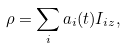Convert formula to latex. <formula><loc_0><loc_0><loc_500><loc_500>\rho = \sum _ { i } a _ { i } ( t ) I _ { i z } ,</formula> 